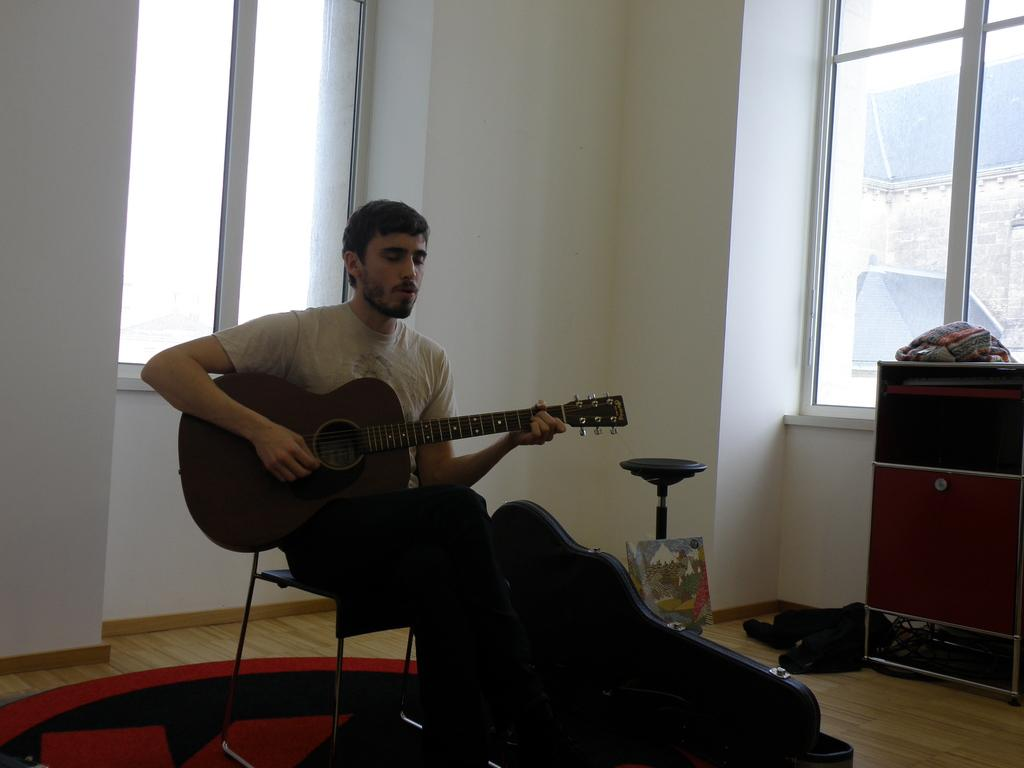What is the person in the image doing? The person is sitting on a chair, playing a guitar, and singing. What object is located on the right side of the image? There is a wooden drawer on the right side of the image. What type of window can be seen in the image? There is a glass window in the image. What type of lace is being used to support the structure in the image? There is no structure or lace present in the image; it features a person playing a guitar and singing, a wooden drawer, and a glass window. 